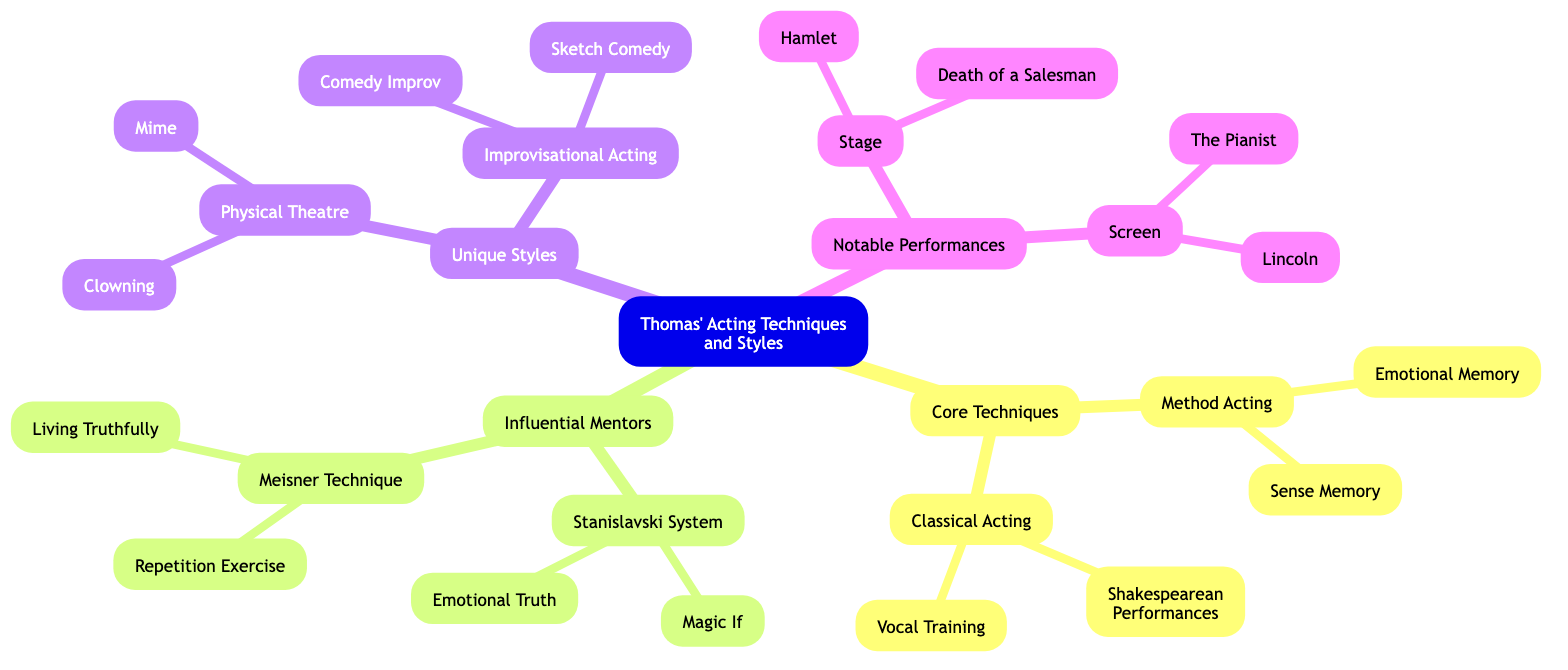What are the two core techniques listed? The diagram shows two main branches under "Core Techniques": "Method Acting" and "Classical Acting".
Answer: Method Acting, Classical Acting How many notable performances are mentioned? The diagram under "Notable Performances" lists two categories: "Stage" and "Screen", each containing two performances, so a total of four performances are indicated.
Answer: 4 What is a principle of the Meisner Technique? The diagram specifies two principles of the Meisner Technique: "Repetition Exercise" and "Living Truthfully". Therefore, either can be an answer, but the question asks for one.
Answer: Repetition Exercise What genre is emphasized in Physical Theatre? The description of "Physical Theatre" in the diagram states it emphasizes "physical expression and movement".
Answer: Physical expression How are Method Acting and Classical Acting different? "Method Acting" is focused on immersion and personal experience, while "Classical Acting" emphasizes external techniques like vocal clarity. The key difference revolves around internal versus external approaches in acting.
Answer: Immersion vs. external techniques What examples are provided for Improvisational Acting? Under "Improvisational Acting," the diagram lists two examples: "Comedy Improv" and "Sketch Comedy".
Answer: Comedy Improv, Sketch Comedy Which influential mentor's system focuses on natural behavior? The description of the "Stanislavski System" in the diagram indicates it is the system that focuses on the actor's natural behavior.
Answer: Stanislavski System What acting style involves creating dialogue spontaneously? The diagram identifies "Improvisational Acting" as the style where actors create dialogue and action spontaneously.
Answer: Improvisational Acting How many examples are given under Classical Acting? The "Classical Acting" section lists two examples: "Shakespearean Performances" and "Vocal Training". Therefore, the total is two.
Answer: 2 